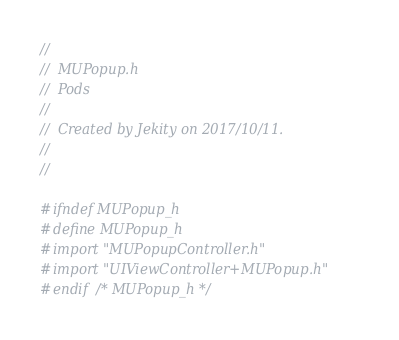<code> <loc_0><loc_0><loc_500><loc_500><_C_>//
//  MUPopup.h
//  Pods
//
//  Created by Jekity on 2017/10/11.
//
//

#ifndef MUPopup_h
#define MUPopup_h
#import "MUPopupController.h"
#import "UIViewController+MUPopup.h"
#endif /* MUPopup_h */
</code> 